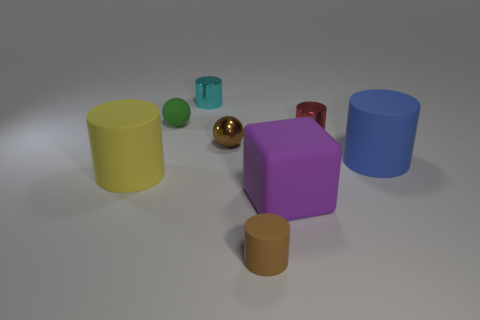Add 1 tiny red balls. How many objects exist? 9 Subtract all blue cylinders. How many cylinders are left? 4 Subtract all tiny brown cylinders. How many cylinders are left? 4 Subtract 1 cubes. How many cubes are left? 0 Subtract 0 blue cubes. How many objects are left? 8 Subtract all balls. How many objects are left? 6 Subtract all brown blocks. Subtract all blue balls. How many blocks are left? 1 Subtract all blue balls. How many cyan cylinders are left? 1 Subtract all tiny brown metal balls. Subtract all yellow metal things. How many objects are left? 7 Add 4 blue cylinders. How many blue cylinders are left? 5 